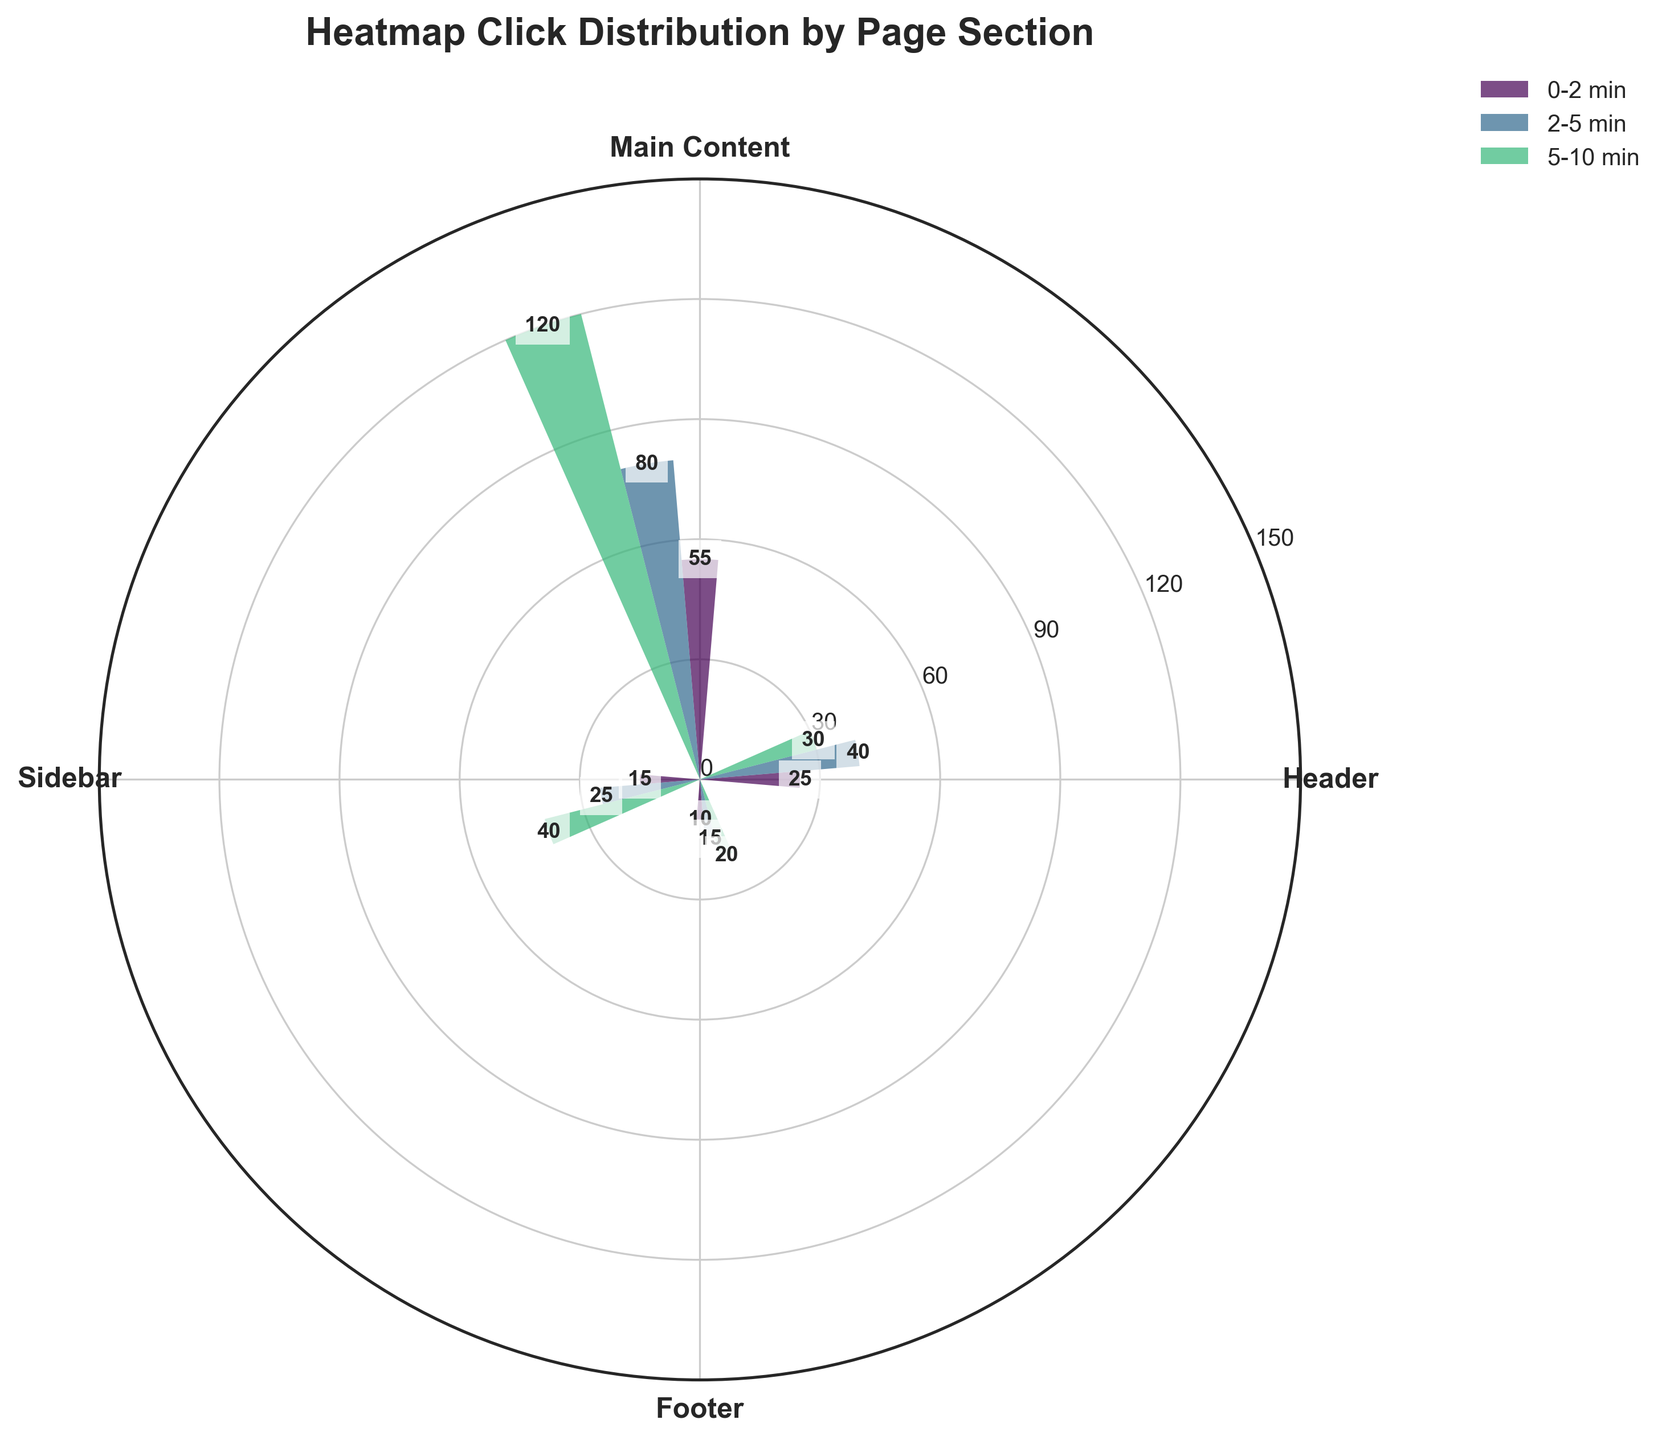What is the title of the figure? The title of the figure is displayed at the top and reads "Heatmap Click Distribution by Page Section."
Answer: Heatmap Click Distribution by Page Section Which page section had the highest click distribution for visit durations between 2-5 minutes? To find out the page section with the highest click distribution for 2-5 minute visits, look at the bars labeled with '2-5 min'. The Main Content section has the highest value in this range.
Answer: Main Content What is the combined click distribution for the Sidebar across the three shown visit durations? Add the values for the Sidebar for each interval: 0-2 min (15), 2-5 min (25), and 5-10 min (40). So, 15 + 25 + 40 = 80.
Answer: 80 Which visit duration group roughly shows an equal distribution across all page sections? Look at the overall height of the bars for each visit duration group. The '0-2 min' group shows relatively smaller and more evenly distributed clicks across all sections.
Answer: 0-2 min Compare the Footer click distribution for 2-5 min and 5-10 min visit durations. Which one is higher? The click distribution values for the Footer are 15 for 2-5 min and 20 for 5-10 min, making 5-10 min higher.
Answer: 5-10 min By how much does the Main Content click distribution for 5-10 min visits exceed the Header click distribution for the same interval? Subtract the Header value from the Main Content value for the 5-10 min interval: 120 (Main Content) - 30 (Header) = 90.
Answer: 90 What is the average click distribution for the Header across the three displayed visit durations? Calculate the average by summing the values for the Header (25 + 40 + 30) and dividing by 3: (25 + 40 + 30) / 3 = 31.67.
Answer: 31.67 Which page section has the lowest click distribution for 0-2 min visit durations? For the 0-2 min visit duration, the Footer has the lowest click distribution with a value of 10.
Answer: Footer 